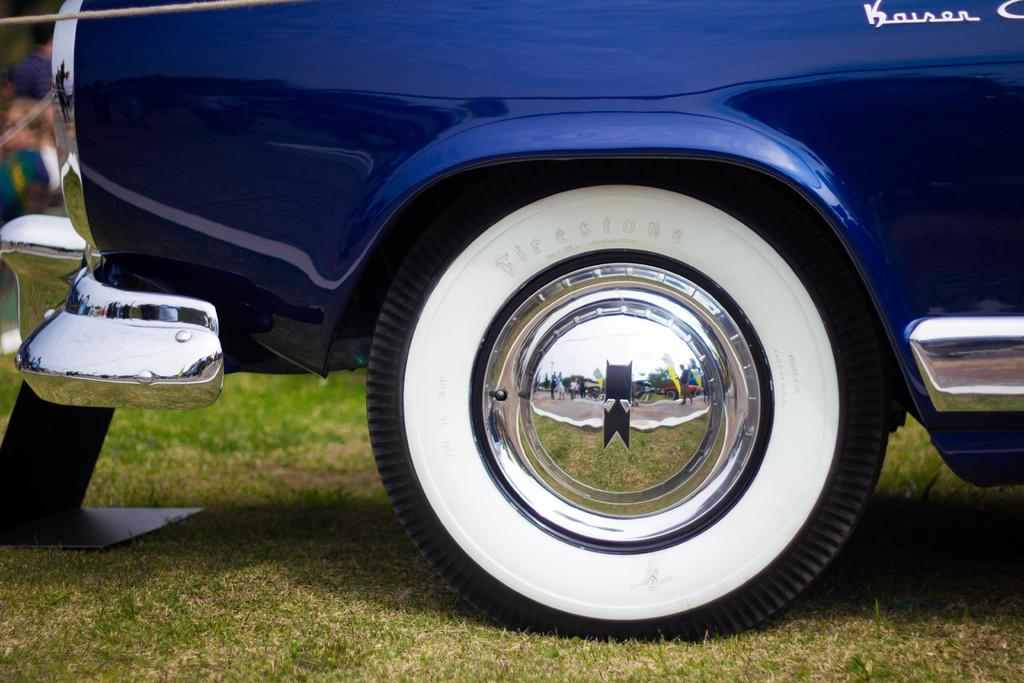What is the main subject in the foreground of the image? There is a car in the foreground of the image. What type of natural environment is visible at the bottom of the image? There is grass at the bottom of the image. What can be seen in the background of the image? There are people in the background of the image. What type of spark can be seen coming from the car's engine in the image? There is no spark visible coming from the car's engine in the image. Is there a clubhouse in the background of the image? There is no clubhouse present in the image; only people are visible in the background. 